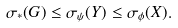Convert formula to latex. <formula><loc_0><loc_0><loc_500><loc_500>\sigma _ { * } ( G ) \leq \sigma _ { \psi } ( Y ) \leq \sigma _ { \phi } ( X ) .</formula> 